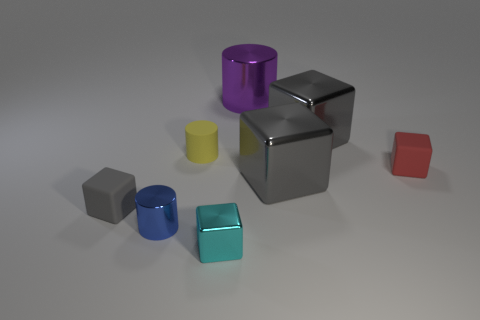How many gray cubes must be subtracted to get 1 gray cubes? 2 Subtract all blue spheres. How many gray cubes are left? 3 Subtract 2 blocks. How many blocks are left? 3 Subtract all red matte blocks. How many blocks are left? 4 Subtract all cyan cubes. How many cubes are left? 4 Subtract all purple cubes. Subtract all purple spheres. How many cubes are left? 5 Add 1 big purple cylinders. How many objects exist? 9 Subtract all blocks. How many objects are left? 3 Add 2 tiny red matte objects. How many tiny red matte objects are left? 3 Add 4 cyan shiny cubes. How many cyan shiny cubes exist? 5 